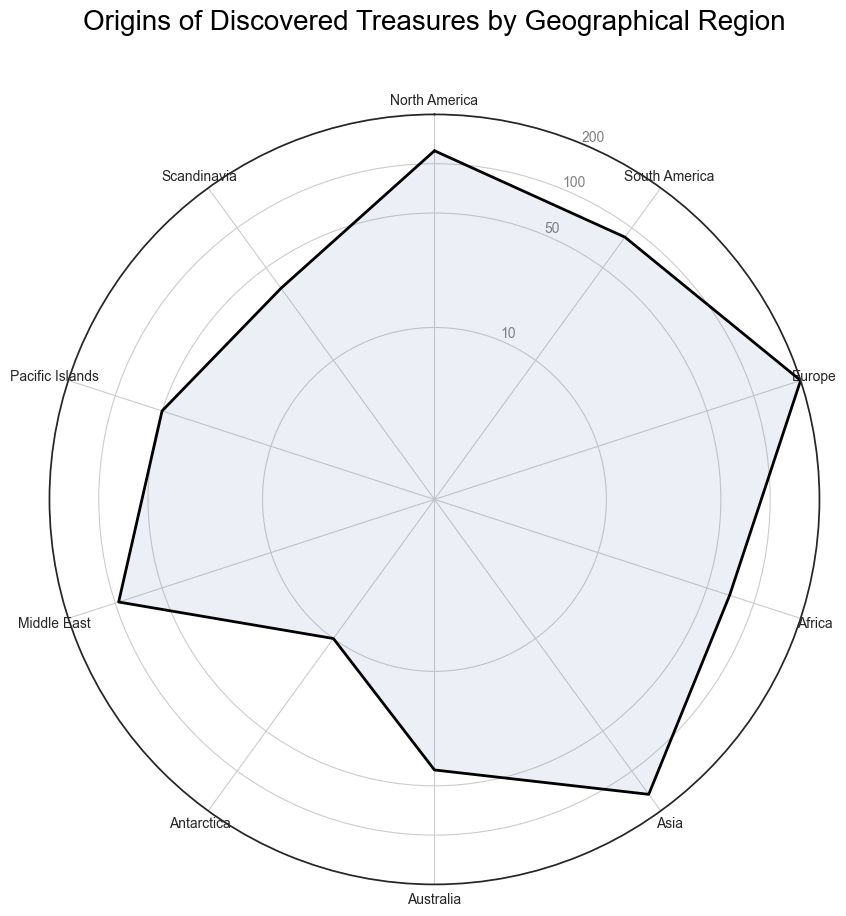Which region has the highest number of discovered treasures? By observing the chart, the region with the largest radial extent (longest spike) represents Europe, indicating the highest number of discovered treasures.
Answer: Europe Which region has fewer discovered treasures, Asia or Africa? We compare the radial lengths for Asia and Africa. Asia shows a longer spike compared to Africa, meaning Africa has fewer discovered treasures.
Answer: Africa What is the combined count of discovered treasures in North America and Antarctica? The treasure count in North America is 120 and in Antarctica is 10. Adding these gives 120 + 10 = 130.
Answer: 130 Is the number of discovered treasures in the Middle East greater than in South America? By comparing the radial lengths, the Middle East has a slightly longer spike than South America, indicating a higher count.
Answer: Yes What is the average number of discovered treasures across Scandinavia, Australia, and the Pacific Islands? Scandinavia: 35, Australia: 40, Pacific Islands: 50. Sum = 35 + 40 + 50 = 125; Average = 125 / 3 ≈ 41.7
Answer: 41.7 Which geographical region has the smallest number of discovered treasures? The shortest spike represents the region with the smallest number of treasures, which corresponds to Antarctica.
Answer: Antarctica How many more treasures are discovered in Europe compared to Africa? Europe has 200 treasures, and Africa has 70. The difference is 200 - 70 = 130.
Answer: 130 Are there more treasures discovered in Asia than in the Middle East? Comparing the lengths, Asia has a longer spike than the Middle East, indicating more treasures.
Answer: Yes What is the ratio of treasures discovered in North America to those in Australia? North America has 120 treasures, and Australia has 40. The ratio is 120 / 40 = 3.
Answer: 3 If we sum up the treasure counts in South America, the Middle East, and the Pacific Islands, what is the total? South America: 85, Middle East: 95, Pacific Islands: 50. Sum = 85 + 95 + 50 = 230.
Answer: 230 